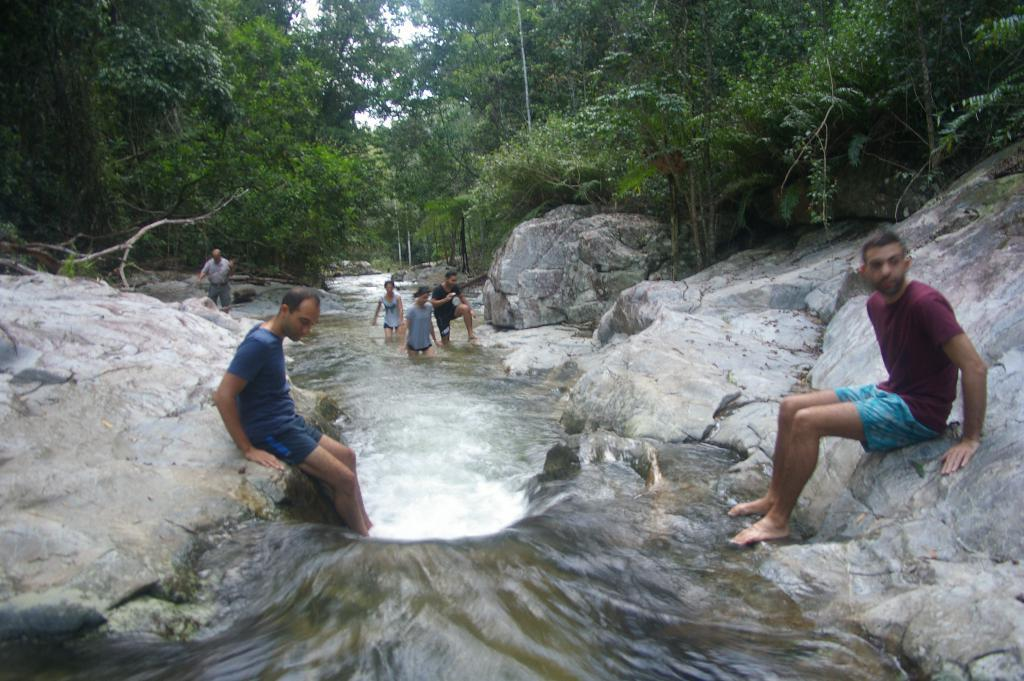Who or what is present in the image? There are people in the image. What is happening in the middle of the image? There is water flow in the middle of the image. What other natural elements can be seen in the image? There are rocks in the image. What can be seen in the distance in the image? There are trees in the background of the image. What is visible above the scene in the image? The sky is visible in the image. What type of orange can be seen in the image? There is no orange present in the image. What order are the people following in the image? The image does not depict a specific order or sequence of actions for the people. 